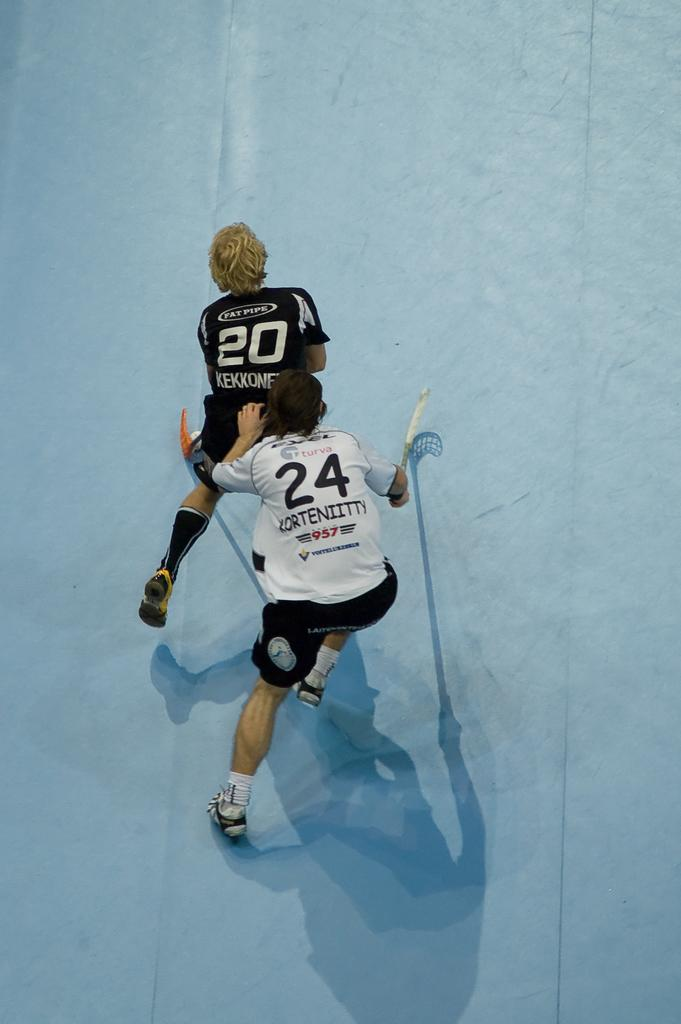<image>
Provide a brief description of the given image. two hockey players with jerseys and number 20 and 24 in a rink 